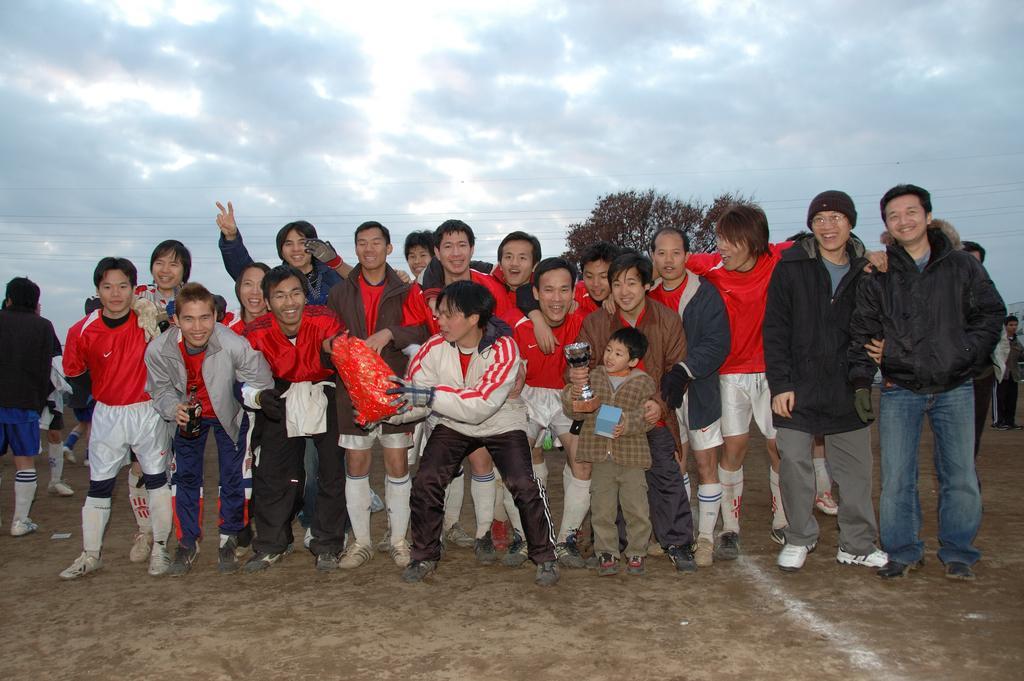Describe this image in one or two sentences. In this image we can see a group of people standing on the ground, among them some are holding the objects, in the background we can see a tree and the sky with clouds. 